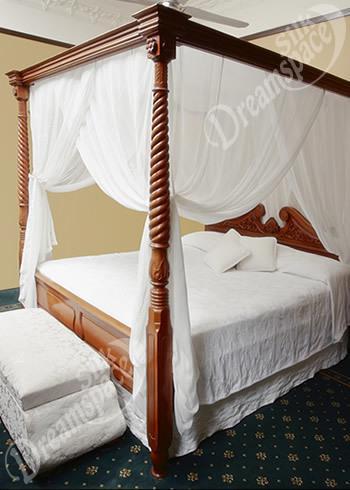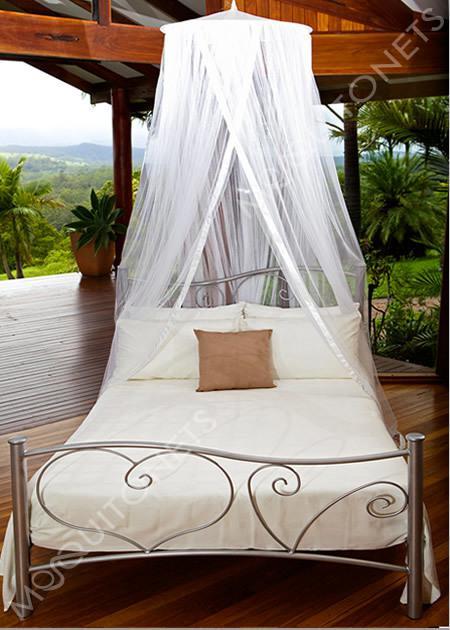The first image is the image on the left, the second image is the image on the right. For the images displayed, is the sentence "All images show a bed covered by a cone-shaped canopy." factually correct? Answer yes or no. No. The first image is the image on the left, the second image is the image on the right. Given the left and right images, does the statement "All bed nets are hanging from a central hook above the bed and draped outward." hold true? Answer yes or no. No. 